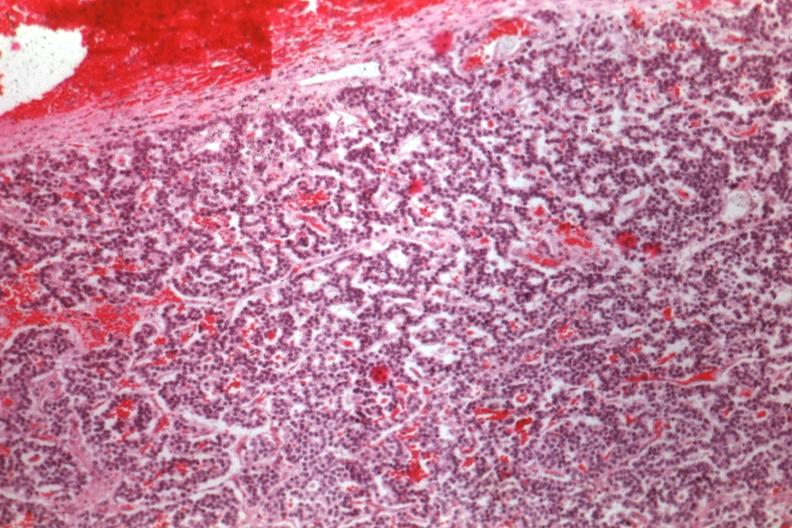s pituitary present?
Answer the question using a single word or phrase. Yes 